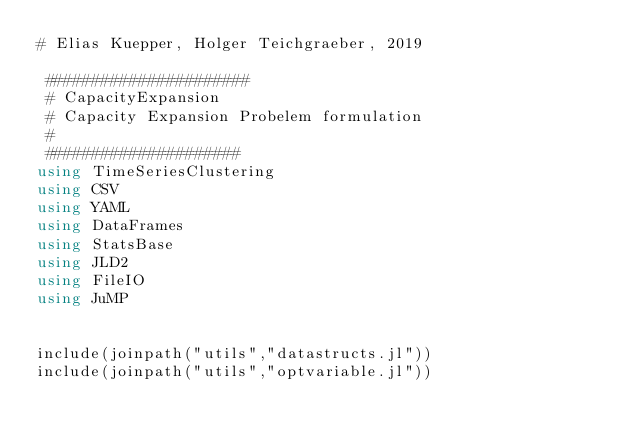Convert code to text. <code><loc_0><loc_0><loc_500><loc_500><_Julia_># Elias Kuepper, Holger Teichgraeber, 2019

 ######################
 # CapacityExpansion
 # Capacity Expansion Probelem formulation
 #
 #####################
using TimeSeriesClustering
using CSV
using YAML
using DataFrames
using StatsBase
using JLD2
using FileIO
using JuMP


include(joinpath("utils","datastructs.jl"))
include(joinpath("utils","optvariable.jl"))</code> 